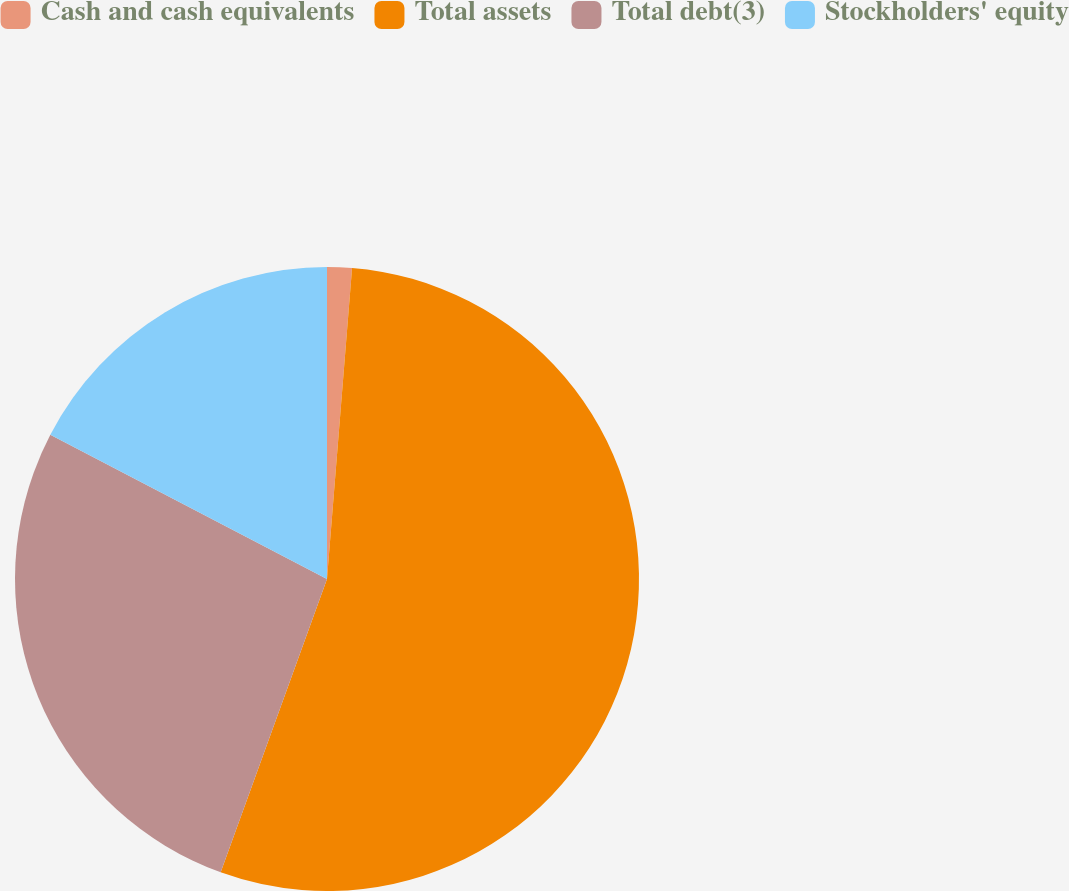Convert chart. <chart><loc_0><loc_0><loc_500><loc_500><pie_chart><fcel>Cash and cash equivalents<fcel>Total assets<fcel>Total debt(3)<fcel>Stockholders' equity<nl><fcel>1.28%<fcel>54.25%<fcel>27.11%<fcel>17.35%<nl></chart> 